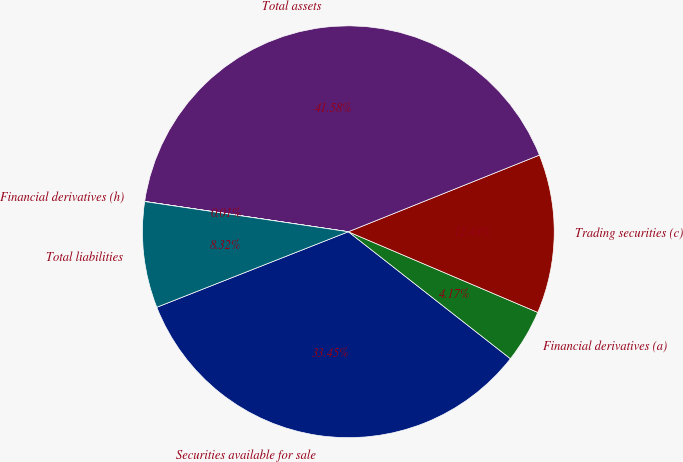<chart> <loc_0><loc_0><loc_500><loc_500><pie_chart><fcel>Securities available for sale<fcel>Financial derivatives (a)<fcel>Trading securities (c)<fcel>Total assets<fcel>Financial derivatives (h)<fcel>Total liabilities<nl><fcel>33.45%<fcel>4.17%<fcel>12.48%<fcel>41.58%<fcel>0.01%<fcel>8.32%<nl></chart> 